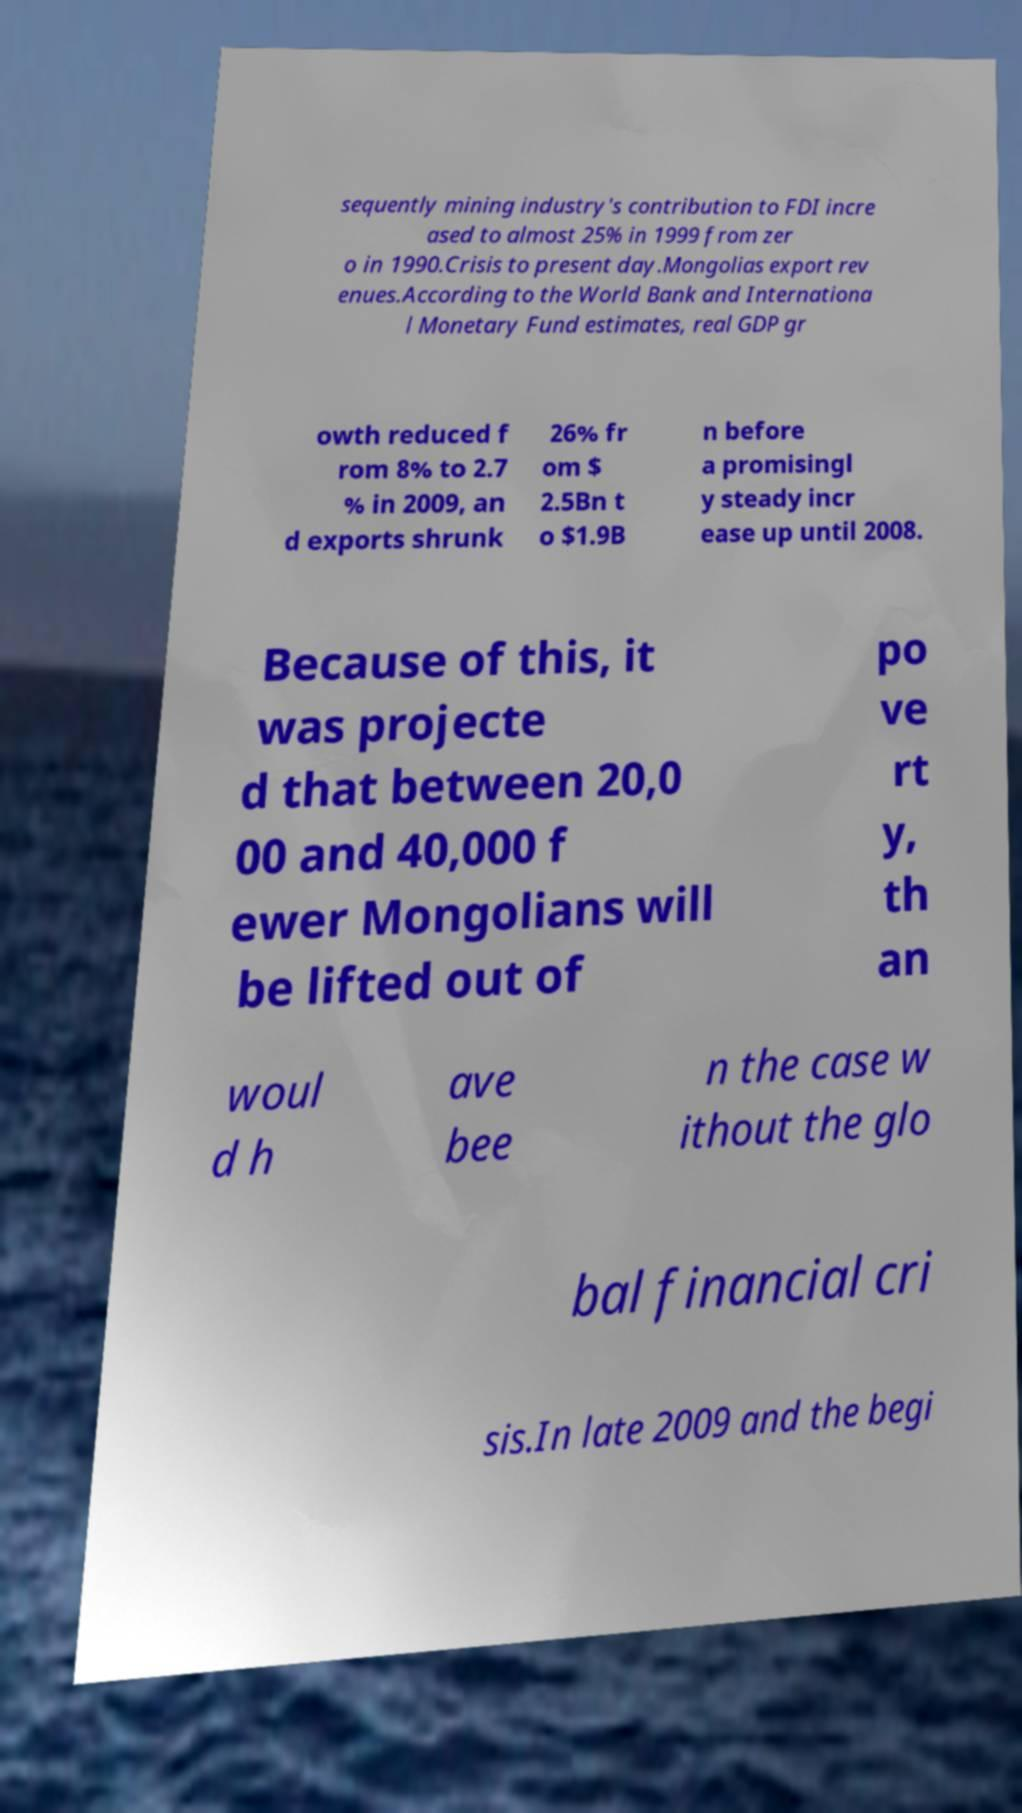I need the written content from this picture converted into text. Can you do that? sequently mining industry's contribution to FDI incre ased to almost 25% in 1999 from zer o in 1990.Crisis to present day.Mongolias export rev enues.According to the World Bank and Internationa l Monetary Fund estimates, real GDP gr owth reduced f rom 8% to 2.7 % in 2009, an d exports shrunk 26% fr om $ 2.5Bn t o $1.9B n before a promisingl y steady incr ease up until 2008. Because of this, it was projecte d that between 20,0 00 and 40,000 f ewer Mongolians will be lifted out of po ve rt y, th an woul d h ave bee n the case w ithout the glo bal financial cri sis.In late 2009 and the begi 